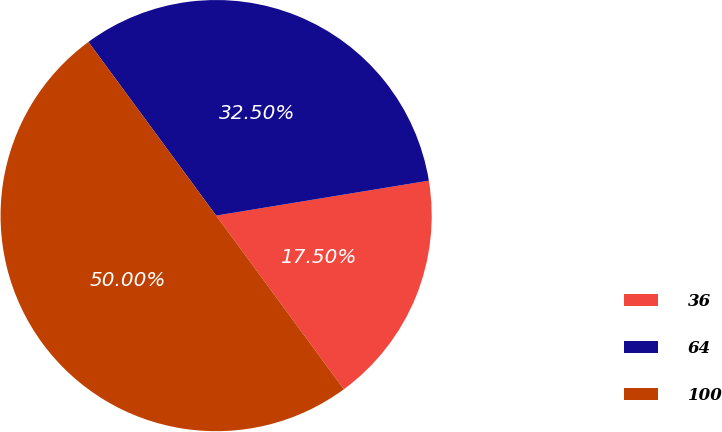Convert chart. <chart><loc_0><loc_0><loc_500><loc_500><pie_chart><fcel>36<fcel>64<fcel>100<nl><fcel>17.5%<fcel>32.5%<fcel>50.0%<nl></chart> 